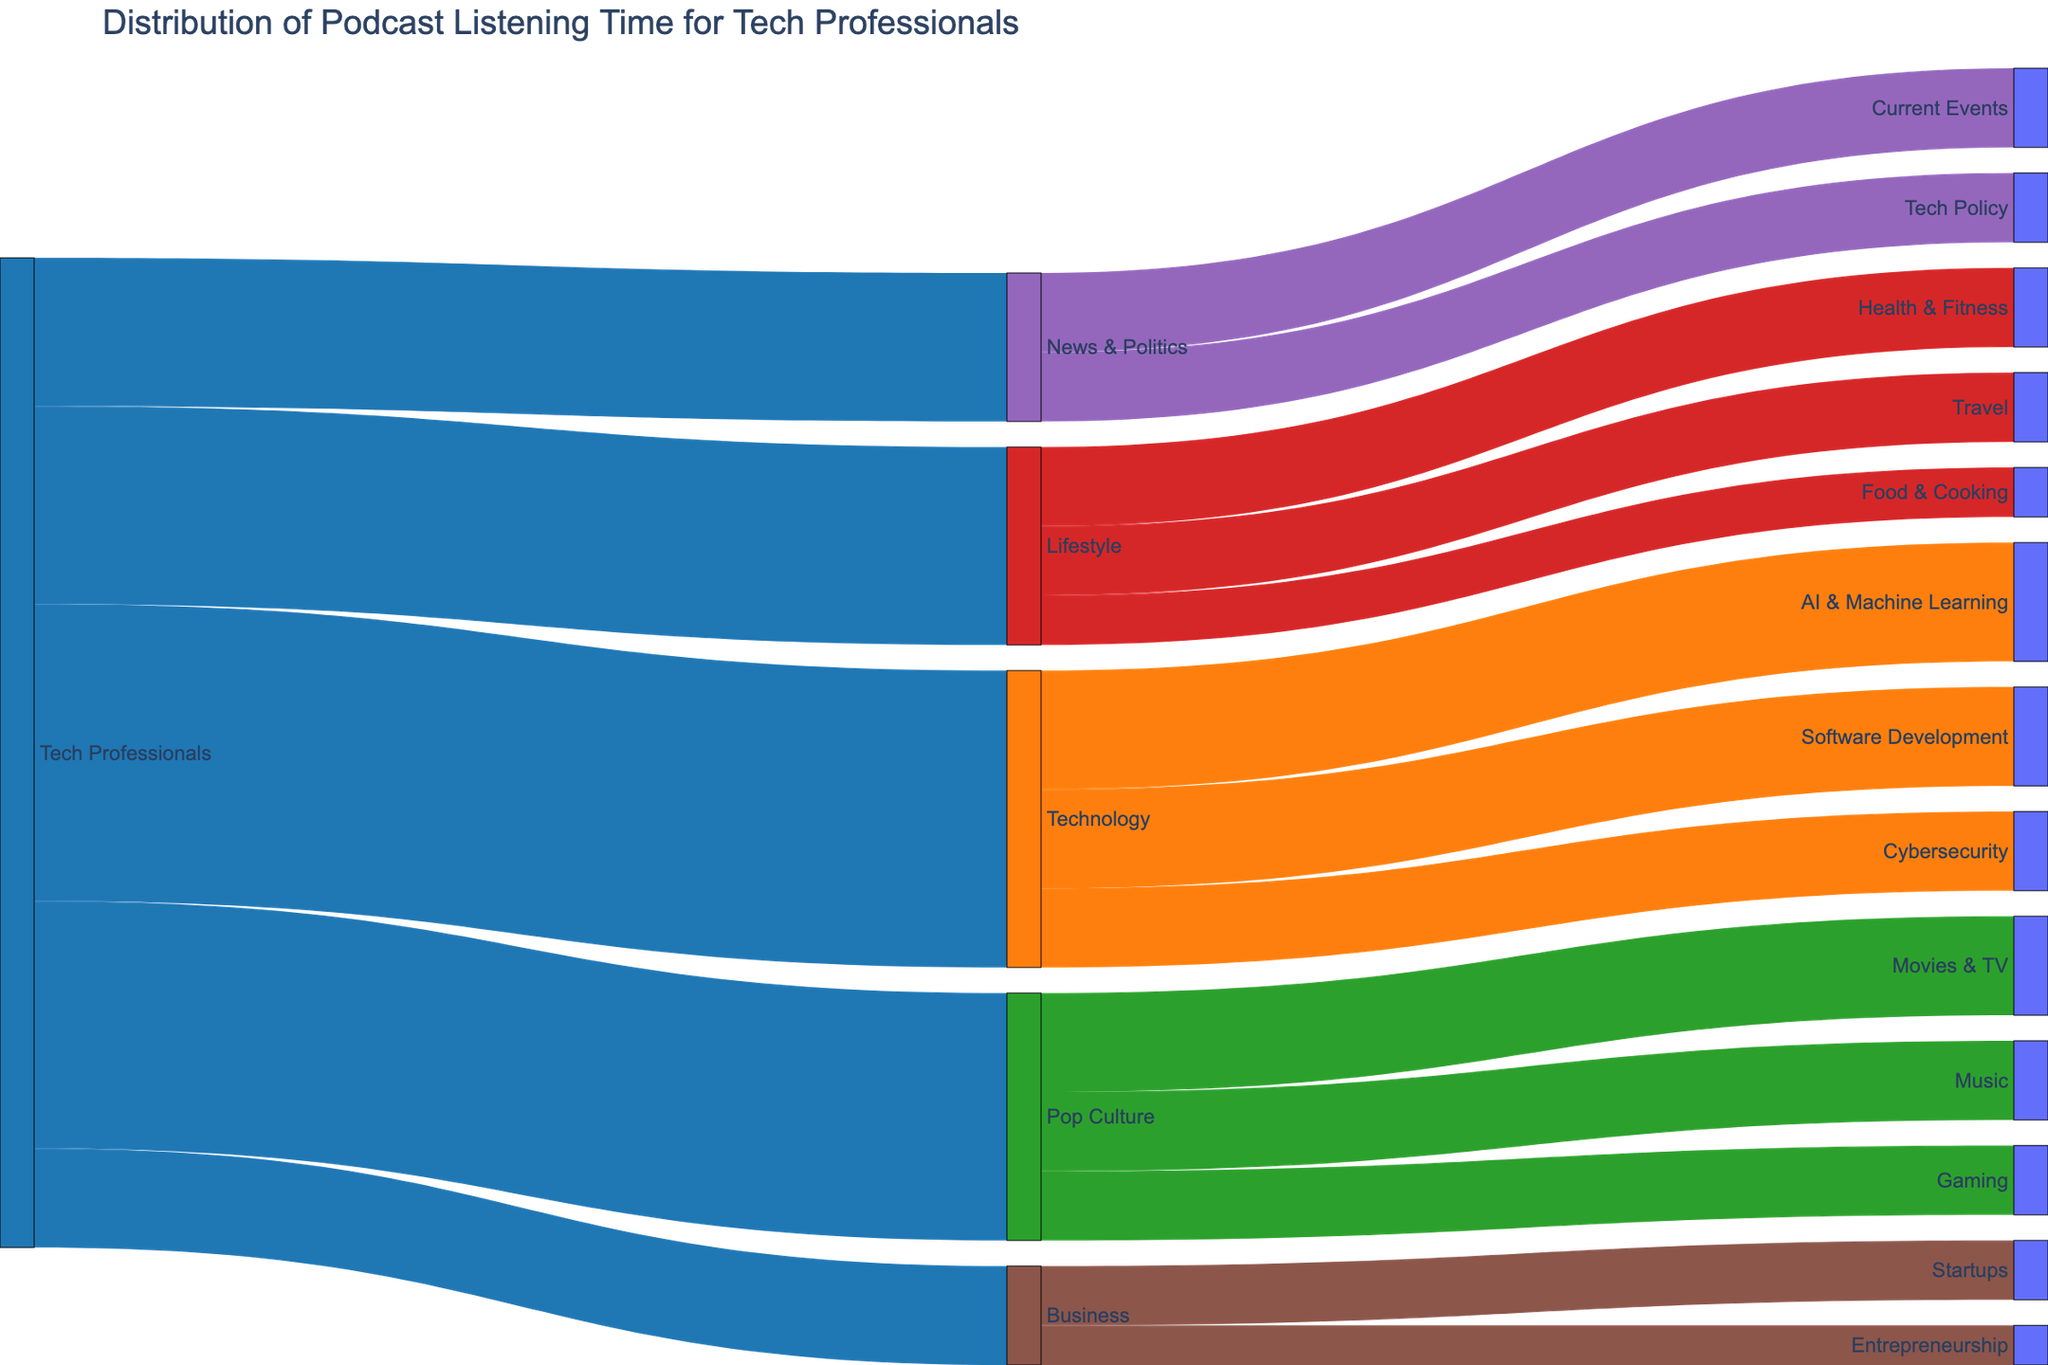What's the title of the Sankey diagram? The title of the diagram is located at the top and summarizes the visual information contained within it. It reads "Distribution of Podcast Listening Time for Tech Professionals".
Answer: Distribution of Podcast Listening Time for Tech Professionals Which genre has the highest listening time among tech professionals? The main branches stemming from "Tech Professionals" have associated values, and the highest value is 30, which leads to "Technology."
Answer: Technology How much more listening time do tech professionals spend on pop culture compared to business podcasts? By comparing the values associated with "Pop Culture" (25) and "Business" (10), the difference is calculated as 25 - 10 = 15.
Answer: 15 What is the combined listening time for "AI & Machine Learning" and "Cybersecurity" under the Technology genre? To find the combined listening time, add the values for "AI & Machine Learning" (12) and "Cybersecurity" (8): 12 + 8 = 20.
Answer: 20 Which specific subcategory under Pop Culture receives equal listening time compared to Tech Policy under News & Politics? According to the diagram, "Tech Policy" under "News & Politics" receives 7. The subcategory under "Pop Culture" with the same listening time is "Gaming."
Answer: Gaming How does the listening time for "Health & Fitness" compare to "Travel" within the Lifestyle genre? "Health & Fitness" has 8 and "Travel" has 7. Therefore, "Health & Fitness" has 1 more listening time than "Travel."
Answer: 1 more What's the total listening time distribution for the Lifestyle genre? Adding the subcategory values under "Lifestyle," the combined listening time is: Health & Fitness (8) + Travel (7) + Food & Cooking (5) = 20.
Answer: 20 Within Technology, which subcategory has the least listening time, and what is that time? Comparing the subcategories under "Technology," "Cybersecurity" has the least listening time with a value of 8.
Answer: Cybersecurity, 8 What percentage of the total listening time is spent on News & Politics? The total listening time is the sum of all initial genre values: 30 (Technology) + 25 (Pop Culture) + 20 (Lifestyle) + 15 (News & Politics) + 10 (Business) = 100. The percentage for "News & Politics" is (15 / 100) * 100% = 15%.
Answer: 15% 